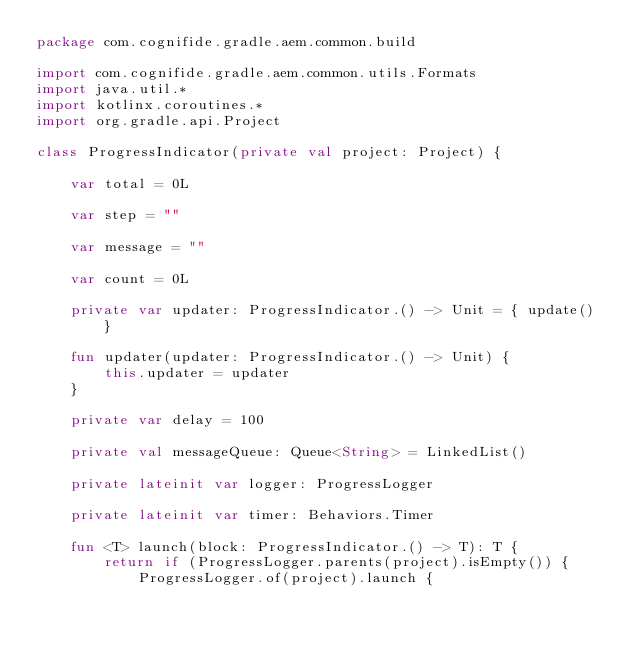Convert code to text. <code><loc_0><loc_0><loc_500><loc_500><_Kotlin_>package com.cognifide.gradle.aem.common.build

import com.cognifide.gradle.aem.common.utils.Formats
import java.util.*
import kotlinx.coroutines.*
import org.gradle.api.Project

class ProgressIndicator(private val project: Project) {

    var total = 0L

    var step = ""

    var message = ""

    var count = 0L

    private var updater: ProgressIndicator.() -> Unit = { update() }

    fun updater(updater: ProgressIndicator.() -> Unit) {
        this.updater = updater
    }

    private var delay = 100

    private val messageQueue: Queue<String> = LinkedList()

    private lateinit var logger: ProgressLogger

    private lateinit var timer: Behaviors.Timer

    fun <T> launch(block: ProgressIndicator.() -> T): T {
        return if (ProgressLogger.parents(project).isEmpty()) {
            ProgressLogger.of(project).launch {</code> 